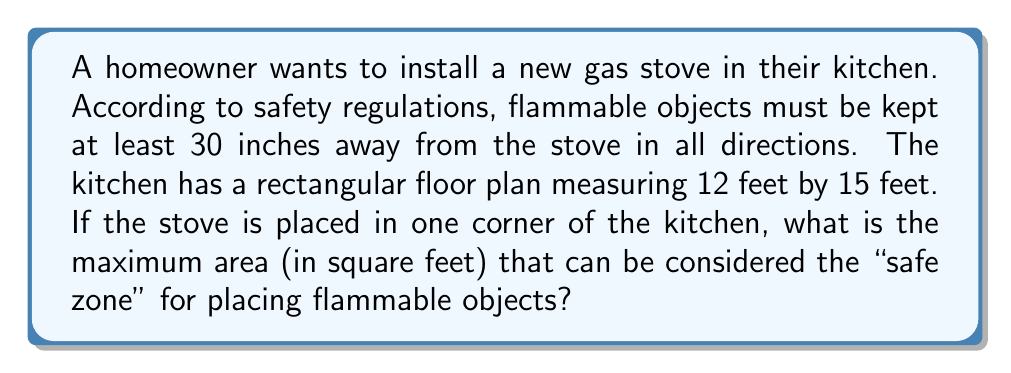Solve this math problem. Let's approach this step-by-step:

1) First, we need to visualize the safe zone. It will be the entire kitchen area minus a quarter circle with a radius of 30 inches (2.5 feet) centered at the corner where the stove is placed.

2) Calculate the total area of the kitchen:
   $A_{kitchen} = 12 \text{ ft} \times 15 \text{ ft} = 180 \text{ ft}^2$

3) Calculate the area of the quarter circle (unsafe zone):
   $A_{unsafe} = \frac{1}{4} \pi r^2 = \frac{1}{4} \pi (2.5\text{ ft})^2 = \frac{25\pi}{16} \text{ ft}^2$

4) The safe zone area is the difference between these:
   $$A_{safe} = A_{kitchen} - A_{unsafe} = 180 - \frac{25\pi}{16} \text{ ft}^2$$

5) Simplify:
   $$A_{safe} = 180 - 4.908738521... \text{ ft}^2 = 175.0912614... \text{ ft}^2$$

6) Rounding to two decimal places for practical purposes:
   $$A_{safe} \approx 175.09 \text{ ft}^2$$

This represents the maximum area where flammable objects can be safely placed in the kitchen.
Answer: $175.09 \text{ ft}^2$ 